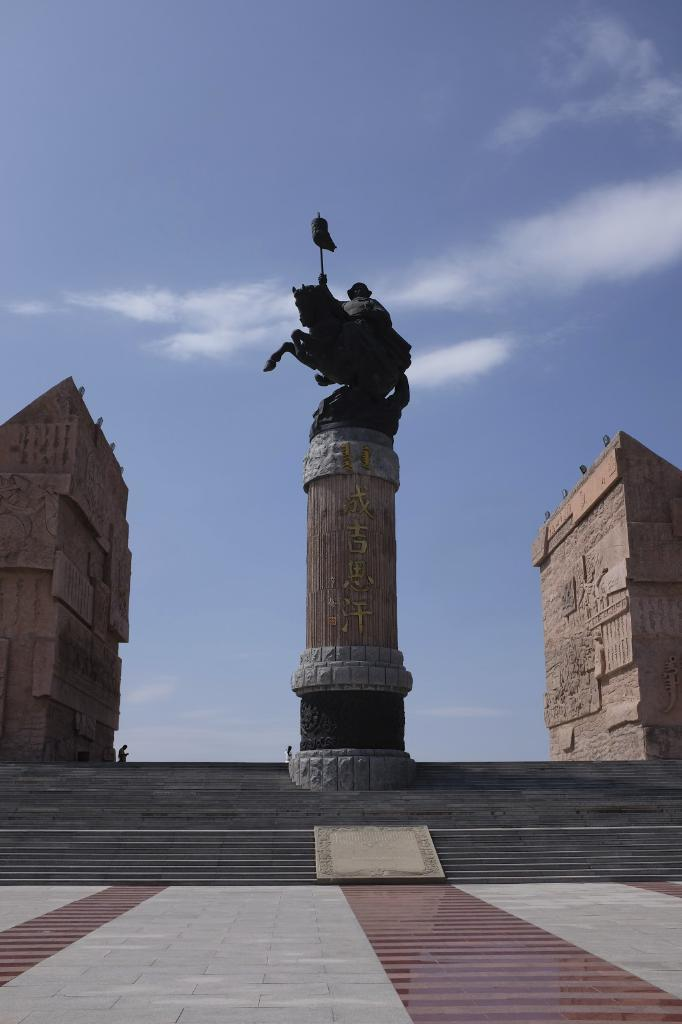What is depicted on the pillar in the image? There is a statue of a man and a horse on a pillar in the image. What architectural feature can be seen in the image? There are steps in the image. What structures are visible on the sides of the image? There are buildings on the sides of the image. What can be seen in the background of the image? The sky is visible in the background of the image, and there are clouds in the sky. What type of memory is being used to store the image? The question refers to a technical aspect of image storage, which is not visible or present in the image itself. Is there an umbrella visible in the image? No, there is no umbrella present in the image. What is the base of the statue made of? The provided facts do not mention the material or base of the statue, so it cannot be determined from the image. 